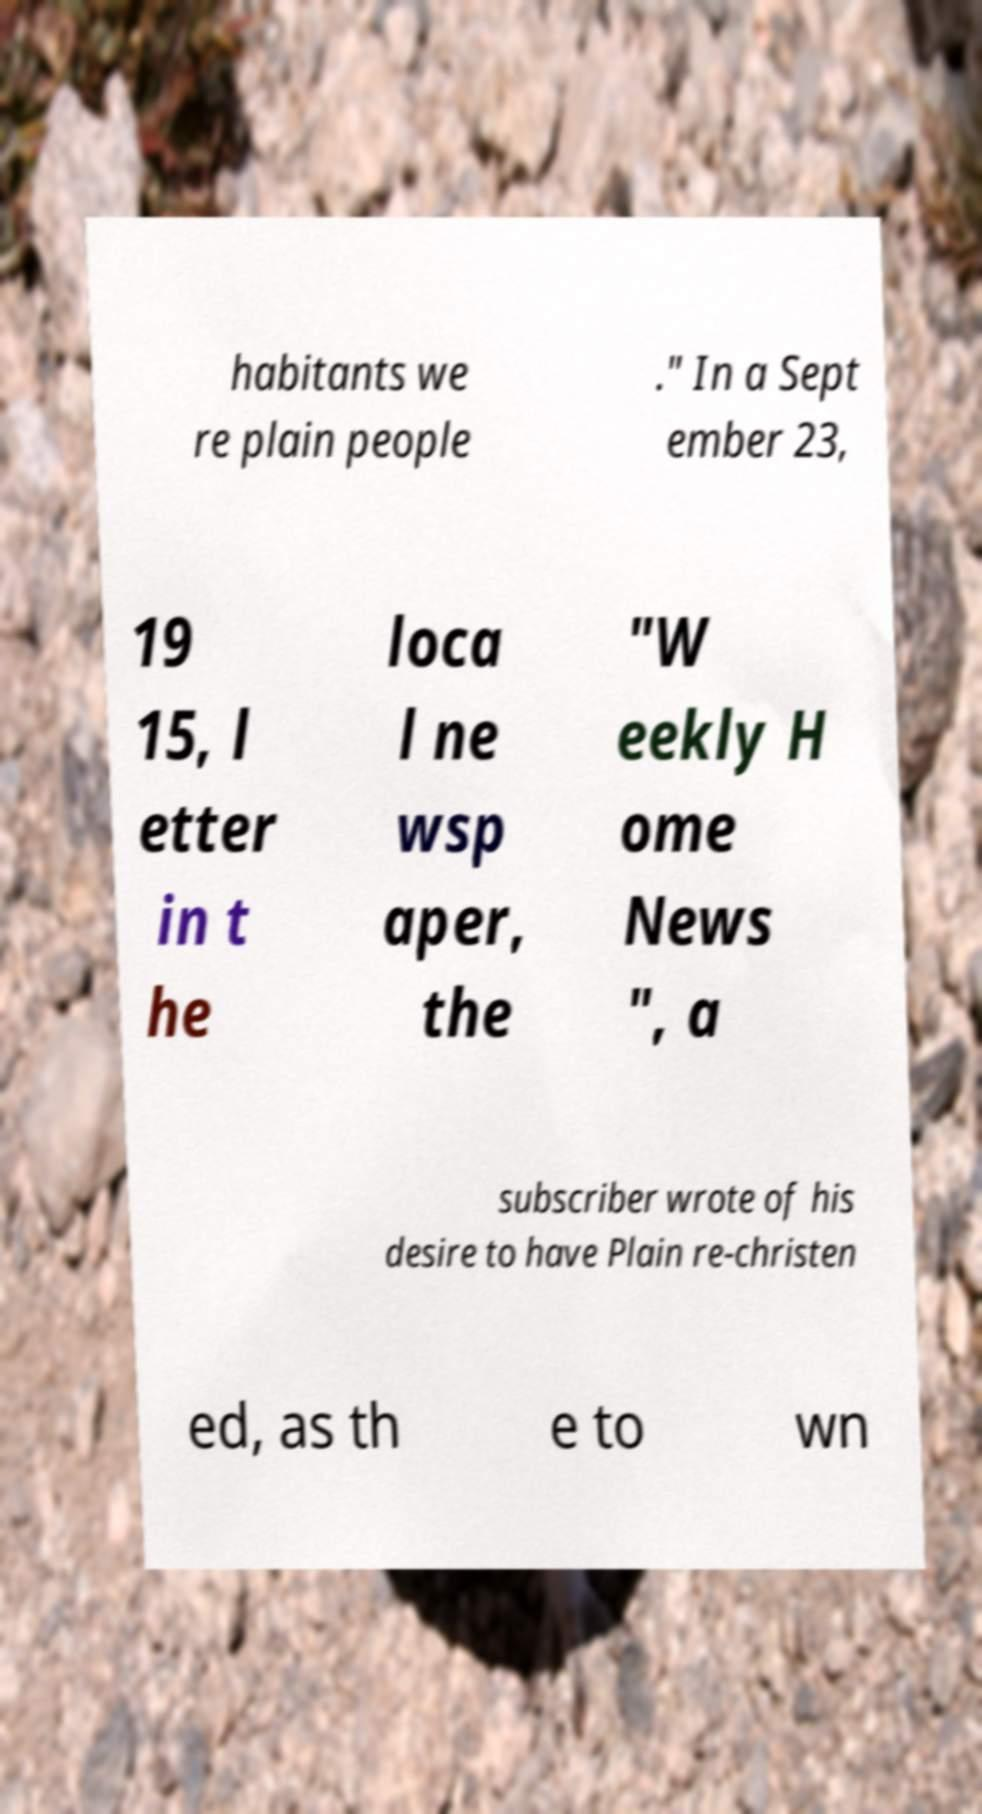I need the written content from this picture converted into text. Can you do that? habitants we re plain people ." In a Sept ember 23, 19 15, l etter in t he loca l ne wsp aper, the "W eekly H ome News ", a subscriber wrote of his desire to have Plain re-christen ed, as th e to wn 